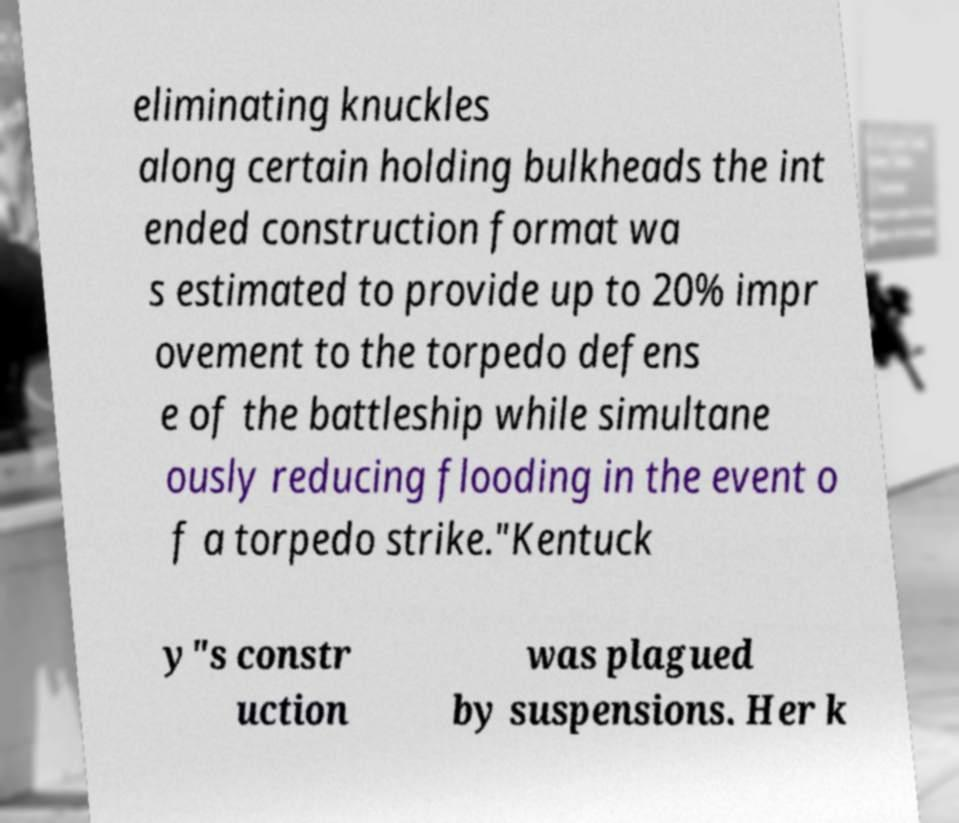For documentation purposes, I need the text within this image transcribed. Could you provide that? eliminating knuckles along certain holding bulkheads the int ended construction format wa s estimated to provide up to 20% impr ovement to the torpedo defens e of the battleship while simultane ously reducing flooding in the event o f a torpedo strike."Kentuck y"s constr uction was plagued by suspensions. Her k 